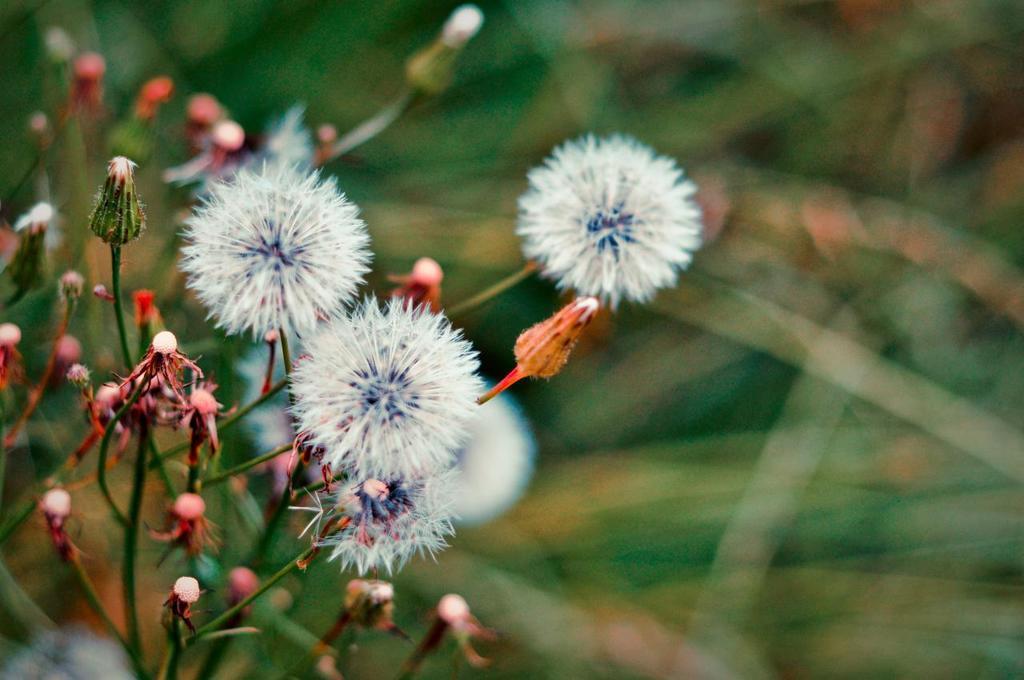Can you describe this image briefly? On the left side, there are plants having flowers. Some of them are in white color. And the background is blurred. 